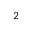<formula> <loc_0><loc_0><loc_500><loc_500>^ { 2 }</formula> 